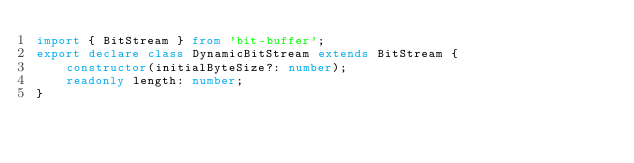Convert code to text. <code><loc_0><loc_0><loc_500><loc_500><_TypeScript_>import { BitStream } from 'bit-buffer';
export declare class DynamicBitStream extends BitStream {
    constructor(initialByteSize?: number);
    readonly length: number;
}
</code> 